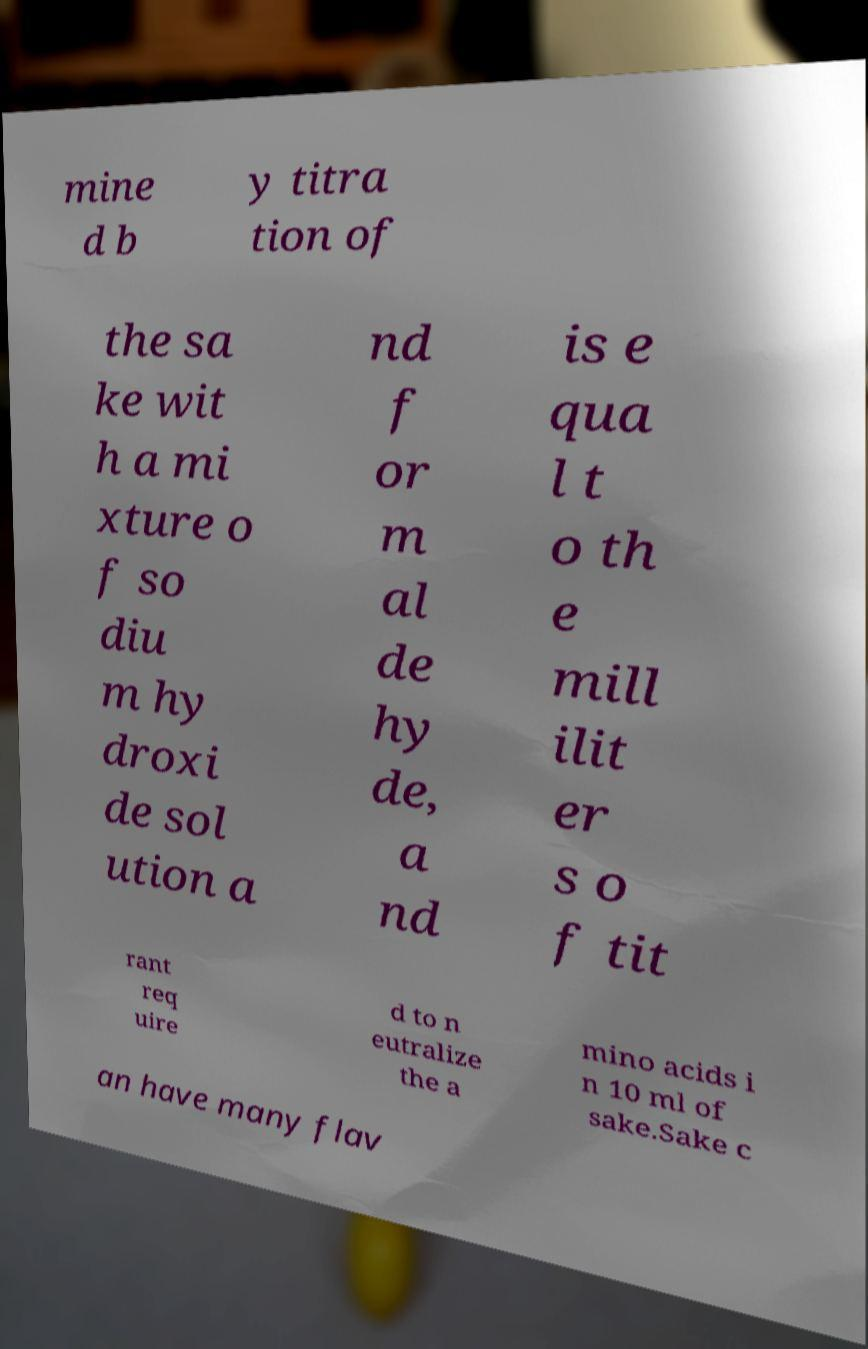I need the written content from this picture converted into text. Can you do that? mine d b y titra tion of the sa ke wit h a mi xture o f so diu m hy droxi de sol ution a nd f or m al de hy de, a nd is e qua l t o th e mill ilit er s o f tit rant req uire d to n eutralize the a mino acids i n 10 ml of sake.Sake c an have many flav 